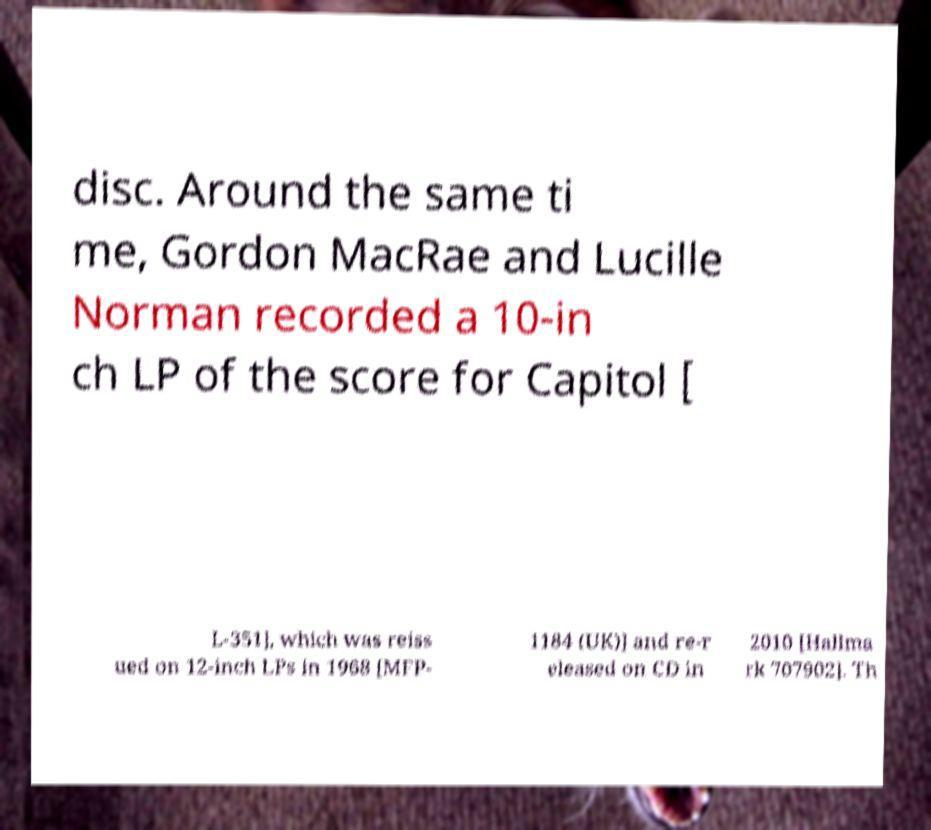Please identify and transcribe the text found in this image. disc. Around the same ti me, Gordon MacRae and Lucille Norman recorded a 10-in ch LP of the score for Capitol [ L-351], which was reiss ued on 12-inch LPs in 1968 [MFP- 1184 (UK)] and re-r eleased on CD in 2010 [Hallma rk 707902]. Th 